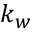Convert formula to latex. <formula><loc_0><loc_0><loc_500><loc_500>k _ { w }</formula> 